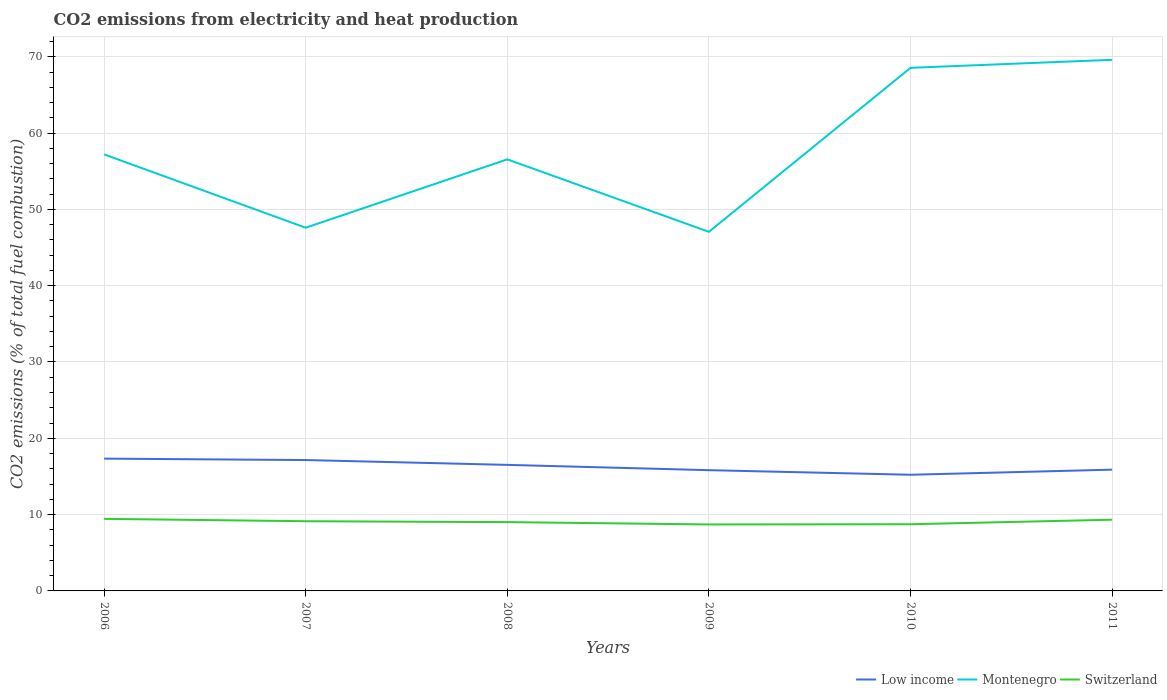Does the line corresponding to Switzerland intersect with the line corresponding to Montenegro?
Your response must be concise. No. Across all years, what is the maximum amount of CO2 emitted in Montenegro?
Give a very brief answer. 47.06. In which year was the amount of CO2 emitted in Low income maximum?
Keep it short and to the point. 2010. What is the total amount of CO2 emitted in Montenegro in the graph?
Keep it short and to the point. -8.96. What is the difference between the highest and the second highest amount of CO2 emitted in Montenegro?
Ensure brevity in your answer.  22.54. What is the difference between the highest and the lowest amount of CO2 emitted in Switzerland?
Your response must be concise. 3. How many lines are there?
Give a very brief answer. 3. What is the difference between two consecutive major ticks on the Y-axis?
Your answer should be compact. 10. Are the values on the major ticks of Y-axis written in scientific E-notation?
Your answer should be compact. No. What is the title of the graph?
Offer a terse response. CO2 emissions from electricity and heat production. What is the label or title of the X-axis?
Provide a short and direct response. Years. What is the label or title of the Y-axis?
Provide a short and direct response. CO2 emissions (% of total fuel combustion). What is the CO2 emissions (% of total fuel combustion) in Low income in 2006?
Ensure brevity in your answer.  17.34. What is the CO2 emissions (% of total fuel combustion) of Montenegro in 2006?
Make the answer very short. 57.21. What is the CO2 emissions (% of total fuel combustion) of Switzerland in 2006?
Offer a very short reply. 9.44. What is the CO2 emissions (% of total fuel combustion) of Low income in 2007?
Provide a short and direct response. 17.15. What is the CO2 emissions (% of total fuel combustion) in Montenegro in 2007?
Offer a terse response. 47.6. What is the CO2 emissions (% of total fuel combustion) in Switzerland in 2007?
Your answer should be compact. 9.13. What is the CO2 emissions (% of total fuel combustion) in Low income in 2008?
Your answer should be very brief. 16.52. What is the CO2 emissions (% of total fuel combustion) in Montenegro in 2008?
Your answer should be very brief. 56.55. What is the CO2 emissions (% of total fuel combustion) in Switzerland in 2008?
Your response must be concise. 9.02. What is the CO2 emissions (% of total fuel combustion) of Low income in 2009?
Offer a terse response. 15.82. What is the CO2 emissions (% of total fuel combustion) in Montenegro in 2009?
Your response must be concise. 47.06. What is the CO2 emissions (% of total fuel combustion) in Switzerland in 2009?
Ensure brevity in your answer.  8.71. What is the CO2 emissions (% of total fuel combustion) of Low income in 2010?
Your answer should be compact. 15.22. What is the CO2 emissions (% of total fuel combustion) of Montenegro in 2010?
Offer a very short reply. 68.55. What is the CO2 emissions (% of total fuel combustion) of Switzerland in 2010?
Provide a succinct answer. 8.74. What is the CO2 emissions (% of total fuel combustion) of Low income in 2011?
Your answer should be compact. 15.89. What is the CO2 emissions (% of total fuel combustion) of Montenegro in 2011?
Ensure brevity in your answer.  69.6. What is the CO2 emissions (% of total fuel combustion) in Switzerland in 2011?
Offer a terse response. 9.33. Across all years, what is the maximum CO2 emissions (% of total fuel combustion) of Low income?
Provide a succinct answer. 17.34. Across all years, what is the maximum CO2 emissions (% of total fuel combustion) of Montenegro?
Your answer should be compact. 69.6. Across all years, what is the maximum CO2 emissions (% of total fuel combustion) of Switzerland?
Your answer should be compact. 9.44. Across all years, what is the minimum CO2 emissions (% of total fuel combustion) in Low income?
Provide a short and direct response. 15.22. Across all years, what is the minimum CO2 emissions (% of total fuel combustion) in Montenegro?
Provide a short and direct response. 47.06. Across all years, what is the minimum CO2 emissions (% of total fuel combustion) of Switzerland?
Give a very brief answer. 8.71. What is the total CO2 emissions (% of total fuel combustion) in Low income in the graph?
Provide a succinct answer. 97.94. What is the total CO2 emissions (% of total fuel combustion) of Montenegro in the graph?
Your answer should be very brief. 346.56. What is the total CO2 emissions (% of total fuel combustion) in Switzerland in the graph?
Keep it short and to the point. 54.38. What is the difference between the CO2 emissions (% of total fuel combustion) in Low income in 2006 and that in 2007?
Ensure brevity in your answer.  0.19. What is the difference between the CO2 emissions (% of total fuel combustion) of Montenegro in 2006 and that in 2007?
Your answer should be compact. 9.61. What is the difference between the CO2 emissions (% of total fuel combustion) of Switzerland in 2006 and that in 2007?
Make the answer very short. 0.31. What is the difference between the CO2 emissions (% of total fuel combustion) in Low income in 2006 and that in 2008?
Provide a short and direct response. 0.82. What is the difference between the CO2 emissions (% of total fuel combustion) of Montenegro in 2006 and that in 2008?
Offer a terse response. 0.65. What is the difference between the CO2 emissions (% of total fuel combustion) in Switzerland in 2006 and that in 2008?
Your response must be concise. 0.43. What is the difference between the CO2 emissions (% of total fuel combustion) of Low income in 2006 and that in 2009?
Your answer should be very brief. 1.51. What is the difference between the CO2 emissions (% of total fuel combustion) in Montenegro in 2006 and that in 2009?
Give a very brief answer. 10.15. What is the difference between the CO2 emissions (% of total fuel combustion) in Switzerland in 2006 and that in 2009?
Your answer should be compact. 0.73. What is the difference between the CO2 emissions (% of total fuel combustion) of Low income in 2006 and that in 2010?
Provide a succinct answer. 2.11. What is the difference between the CO2 emissions (% of total fuel combustion) of Montenegro in 2006 and that in 2010?
Keep it short and to the point. -11.34. What is the difference between the CO2 emissions (% of total fuel combustion) in Switzerland in 2006 and that in 2010?
Ensure brevity in your answer.  0.71. What is the difference between the CO2 emissions (% of total fuel combustion) of Low income in 2006 and that in 2011?
Your response must be concise. 1.44. What is the difference between the CO2 emissions (% of total fuel combustion) of Montenegro in 2006 and that in 2011?
Provide a short and direct response. -12.39. What is the difference between the CO2 emissions (% of total fuel combustion) in Switzerland in 2006 and that in 2011?
Your answer should be very brief. 0.11. What is the difference between the CO2 emissions (% of total fuel combustion) in Low income in 2007 and that in 2008?
Your response must be concise. 0.63. What is the difference between the CO2 emissions (% of total fuel combustion) of Montenegro in 2007 and that in 2008?
Provide a short and direct response. -8.96. What is the difference between the CO2 emissions (% of total fuel combustion) in Switzerland in 2007 and that in 2008?
Your answer should be compact. 0.12. What is the difference between the CO2 emissions (% of total fuel combustion) in Low income in 2007 and that in 2009?
Your answer should be very brief. 1.33. What is the difference between the CO2 emissions (% of total fuel combustion) of Montenegro in 2007 and that in 2009?
Provide a succinct answer. 0.54. What is the difference between the CO2 emissions (% of total fuel combustion) in Switzerland in 2007 and that in 2009?
Offer a very short reply. 0.42. What is the difference between the CO2 emissions (% of total fuel combustion) in Low income in 2007 and that in 2010?
Offer a very short reply. 1.93. What is the difference between the CO2 emissions (% of total fuel combustion) of Montenegro in 2007 and that in 2010?
Give a very brief answer. -20.95. What is the difference between the CO2 emissions (% of total fuel combustion) in Switzerland in 2007 and that in 2010?
Ensure brevity in your answer.  0.4. What is the difference between the CO2 emissions (% of total fuel combustion) of Low income in 2007 and that in 2011?
Provide a succinct answer. 1.26. What is the difference between the CO2 emissions (% of total fuel combustion) in Montenegro in 2007 and that in 2011?
Give a very brief answer. -22. What is the difference between the CO2 emissions (% of total fuel combustion) in Switzerland in 2007 and that in 2011?
Ensure brevity in your answer.  -0.2. What is the difference between the CO2 emissions (% of total fuel combustion) in Low income in 2008 and that in 2009?
Give a very brief answer. 0.69. What is the difference between the CO2 emissions (% of total fuel combustion) of Montenegro in 2008 and that in 2009?
Keep it short and to the point. 9.5. What is the difference between the CO2 emissions (% of total fuel combustion) in Switzerland in 2008 and that in 2009?
Your answer should be compact. 0.31. What is the difference between the CO2 emissions (% of total fuel combustion) of Low income in 2008 and that in 2010?
Give a very brief answer. 1.29. What is the difference between the CO2 emissions (% of total fuel combustion) in Montenegro in 2008 and that in 2010?
Your answer should be compact. -11.99. What is the difference between the CO2 emissions (% of total fuel combustion) of Switzerland in 2008 and that in 2010?
Keep it short and to the point. 0.28. What is the difference between the CO2 emissions (% of total fuel combustion) of Low income in 2008 and that in 2011?
Keep it short and to the point. 0.63. What is the difference between the CO2 emissions (% of total fuel combustion) in Montenegro in 2008 and that in 2011?
Your answer should be compact. -13.05. What is the difference between the CO2 emissions (% of total fuel combustion) of Switzerland in 2008 and that in 2011?
Provide a succinct answer. -0.31. What is the difference between the CO2 emissions (% of total fuel combustion) in Low income in 2009 and that in 2010?
Keep it short and to the point. 0.6. What is the difference between the CO2 emissions (% of total fuel combustion) in Montenegro in 2009 and that in 2010?
Ensure brevity in your answer.  -21.49. What is the difference between the CO2 emissions (% of total fuel combustion) of Switzerland in 2009 and that in 2010?
Your answer should be very brief. -0.03. What is the difference between the CO2 emissions (% of total fuel combustion) in Low income in 2009 and that in 2011?
Your response must be concise. -0.07. What is the difference between the CO2 emissions (% of total fuel combustion) of Montenegro in 2009 and that in 2011?
Make the answer very short. -22.54. What is the difference between the CO2 emissions (% of total fuel combustion) in Switzerland in 2009 and that in 2011?
Ensure brevity in your answer.  -0.62. What is the difference between the CO2 emissions (% of total fuel combustion) in Low income in 2010 and that in 2011?
Offer a terse response. -0.67. What is the difference between the CO2 emissions (% of total fuel combustion) in Montenegro in 2010 and that in 2011?
Your answer should be very brief. -1.05. What is the difference between the CO2 emissions (% of total fuel combustion) in Switzerland in 2010 and that in 2011?
Offer a terse response. -0.59. What is the difference between the CO2 emissions (% of total fuel combustion) of Low income in 2006 and the CO2 emissions (% of total fuel combustion) of Montenegro in 2007?
Provide a succinct answer. -30.26. What is the difference between the CO2 emissions (% of total fuel combustion) of Low income in 2006 and the CO2 emissions (% of total fuel combustion) of Switzerland in 2007?
Offer a terse response. 8.2. What is the difference between the CO2 emissions (% of total fuel combustion) in Montenegro in 2006 and the CO2 emissions (% of total fuel combustion) in Switzerland in 2007?
Keep it short and to the point. 48.07. What is the difference between the CO2 emissions (% of total fuel combustion) of Low income in 2006 and the CO2 emissions (% of total fuel combustion) of Montenegro in 2008?
Keep it short and to the point. -39.22. What is the difference between the CO2 emissions (% of total fuel combustion) in Low income in 2006 and the CO2 emissions (% of total fuel combustion) in Switzerland in 2008?
Offer a very short reply. 8.32. What is the difference between the CO2 emissions (% of total fuel combustion) of Montenegro in 2006 and the CO2 emissions (% of total fuel combustion) of Switzerland in 2008?
Your answer should be very brief. 48.19. What is the difference between the CO2 emissions (% of total fuel combustion) of Low income in 2006 and the CO2 emissions (% of total fuel combustion) of Montenegro in 2009?
Keep it short and to the point. -29.72. What is the difference between the CO2 emissions (% of total fuel combustion) of Low income in 2006 and the CO2 emissions (% of total fuel combustion) of Switzerland in 2009?
Make the answer very short. 8.62. What is the difference between the CO2 emissions (% of total fuel combustion) of Montenegro in 2006 and the CO2 emissions (% of total fuel combustion) of Switzerland in 2009?
Your answer should be very brief. 48.5. What is the difference between the CO2 emissions (% of total fuel combustion) in Low income in 2006 and the CO2 emissions (% of total fuel combustion) in Montenegro in 2010?
Ensure brevity in your answer.  -51.21. What is the difference between the CO2 emissions (% of total fuel combustion) in Low income in 2006 and the CO2 emissions (% of total fuel combustion) in Switzerland in 2010?
Your response must be concise. 8.6. What is the difference between the CO2 emissions (% of total fuel combustion) of Montenegro in 2006 and the CO2 emissions (% of total fuel combustion) of Switzerland in 2010?
Your answer should be compact. 48.47. What is the difference between the CO2 emissions (% of total fuel combustion) of Low income in 2006 and the CO2 emissions (% of total fuel combustion) of Montenegro in 2011?
Offer a terse response. -52.26. What is the difference between the CO2 emissions (% of total fuel combustion) of Low income in 2006 and the CO2 emissions (% of total fuel combustion) of Switzerland in 2011?
Provide a short and direct response. 8. What is the difference between the CO2 emissions (% of total fuel combustion) in Montenegro in 2006 and the CO2 emissions (% of total fuel combustion) in Switzerland in 2011?
Ensure brevity in your answer.  47.87. What is the difference between the CO2 emissions (% of total fuel combustion) of Low income in 2007 and the CO2 emissions (% of total fuel combustion) of Montenegro in 2008?
Give a very brief answer. -39.4. What is the difference between the CO2 emissions (% of total fuel combustion) of Low income in 2007 and the CO2 emissions (% of total fuel combustion) of Switzerland in 2008?
Ensure brevity in your answer.  8.13. What is the difference between the CO2 emissions (% of total fuel combustion) in Montenegro in 2007 and the CO2 emissions (% of total fuel combustion) in Switzerland in 2008?
Your answer should be very brief. 38.58. What is the difference between the CO2 emissions (% of total fuel combustion) of Low income in 2007 and the CO2 emissions (% of total fuel combustion) of Montenegro in 2009?
Ensure brevity in your answer.  -29.91. What is the difference between the CO2 emissions (% of total fuel combustion) in Low income in 2007 and the CO2 emissions (% of total fuel combustion) in Switzerland in 2009?
Ensure brevity in your answer.  8.44. What is the difference between the CO2 emissions (% of total fuel combustion) in Montenegro in 2007 and the CO2 emissions (% of total fuel combustion) in Switzerland in 2009?
Offer a terse response. 38.89. What is the difference between the CO2 emissions (% of total fuel combustion) in Low income in 2007 and the CO2 emissions (% of total fuel combustion) in Montenegro in 2010?
Your answer should be compact. -51.4. What is the difference between the CO2 emissions (% of total fuel combustion) in Low income in 2007 and the CO2 emissions (% of total fuel combustion) in Switzerland in 2010?
Ensure brevity in your answer.  8.41. What is the difference between the CO2 emissions (% of total fuel combustion) of Montenegro in 2007 and the CO2 emissions (% of total fuel combustion) of Switzerland in 2010?
Your response must be concise. 38.86. What is the difference between the CO2 emissions (% of total fuel combustion) of Low income in 2007 and the CO2 emissions (% of total fuel combustion) of Montenegro in 2011?
Make the answer very short. -52.45. What is the difference between the CO2 emissions (% of total fuel combustion) of Low income in 2007 and the CO2 emissions (% of total fuel combustion) of Switzerland in 2011?
Give a very brief answer. 7.82. What is the difference between the CO2 emissions (% of total fuel combustion) of Montenegro in 2007 and the CO2 emissions (% of total fuel combustion) of Switzerland in 2011?
Your answer should be very brief. 38.26. What is the difference between the CO2 emissions (% of total fuel combustion) of Low income in 2008 and the CO2 emissions (% of total fuel combustion) of Montenegro in 2009?
Make the answer very short. -30.54. What is the difference between the CO2 emissions (% of total fuel combustion) of Low income in 2008 and the CO2 emissions (% of total fuel combustion) of Switzerland in 2009?
Provide a succinct answer. 7.81. What is the difference between the CO2 emissions (% of total fuel combustion) of Montenegro in 2008 and the CO2 emissions (% of total fuel combustion) of Switzerland in 2009?
Offer a terse response. 47.84. What is the difference between the CO2 emissions (% of total fuel combustion) in Low income in 2008 and the CO2 emissions (% of total fuel combustion) in Montenegro in 2010?
Ensure brevity in your answer.  -52.03. What is the difference between the CO2 emissions (% of total fuel combustion) in Low income in 2008 and the CO2 emissions (% of total fuel combustion) in Switzerland in 2010?
Your answer should be very brief. 7.78. What is the difference between the CO2 emissions (% of total fuel combustion) of Montenegro in 2008 and the CO2 emissions (% of total fuel combustion) of Switzerland in 2010?
Offer a terse response. 47.82. What is the difference between the CO2 emissions (% of total fuel combustion) of Low income in 2008 and the CO2 emissions (% of total fuel combustion) of Montenegro in 2011?
Make the answer very short. -53.08. What is the difference between the CO2 emissions (% of total fuel combustion) in Low income in 2008 and the CO2 emissions (% of total fuel combustion) in Switzerland in 2011?
Ensure brevity in your answer.  7.19. What is the difference between the CO2 emissions (% of total fuel combustion) of Montenegro in 2008 and the CO2 emissions (% of total fuel combustion) of Switzerland in 2011?
Your answer should be very brief. 47.22. What is the difference between the CO2 emissions (% of total fuel combustion) in Low income in 2009 and the CO2 emissions (% of total fuel combustion) in Montenegro in 2010?
Provide a short and direct response. -52.72. What is the difference between the CO2 emissions (% of total fuel combustion) in Low income in 2009 and the CO2 emissions (% of total fuel combustion) in Switzerland in 2010?
Your answer should be compact. 7.09. What is the difference between the CO2 emissions (% of total fuel combustion) of Montenegro in 2009 and the CO2 emissions (% of total fuel combustion) of Switzerland in 2010?
Offer a terse response. 38.32. What is the difference between the CO2 emissions (% of total fuel combustion) of Low income in 2009 and the CO2 emissions (% of total fuel combustion) of Montenegro in 2011?
Offer a very short reply. -53.78. What is the difference between the CO2 emissions (% of total fuel combustion) in Low income in 2009 and the CO2 emissions (% of total fuel combustion) in Switzerland in 2011?
Keep it short and to the point. 6.49. What is the difference between the CO2 emissions (% of total fuel combustion) of Montenegro in 2009 and the CO2 emissions (% of total fuel combustion) of Switzerland in 2011?
Your answer should be compact. 37.73. What is the difference between the CO2 emissions (% of total fuel combustion) in Low income in 2010 and the CO2 emissions (% of total fuel combustion) in Montenegro in 2011?
Your answer should be compact. -54.38. What is the difference between the CO2 emissions (% of total fuel combustion) in Low income in 2010 and the CO2 emissions (% of total fuel combustion) in Switzerland in 2011?
Offer a very short reply. 5.89. What is the difference between the CO2 emissions (% of total fuel combustion) in Montenegro in 2010 and the CO2 emissions (% of total fuel combustion) in Switzerland in 2011?
Provide a short and direct response. 59.22. What is the average CO2 emissions (% of total fuel combustion) in Low income per year?
Make the answer very short. 16.32. What is the average CO2 emissions (% of total fuel combustion) in Montenegro per year?
Offer a very short reply. 57.76. What is the average CO2 emissions (% of total fuel combustion) of Switzerland per year?
Make the answer very short. 9.06. In the year 2006, what is the difference between the CO2 emissions (% of total fuel combustion) in Low income and CO2 emissions (% of total fuel combustion) in Montenegro?
Keep it short and to the point. -39.87. In the year 2006, what is the difference between the CO2 emissions (% of total fuel combustion) in Low income and CO2 emissions (% of total fuel combustion) in Switzerland?
Your answer should be very brief. 7.89. In the year 2006, what is the difference between the CO2 emissions (% of total fuel combustion) in Montenegro and CO2 emissions (% of total fuel combustion) in Switzerland?
Offer a terse response. 47.76. In the year 2007, what is the difference between the CO2 emissions (% of total fuel combustion) in Low income and CO2 emissions (% of total fuel combustion) in Montenegro?
Your response must be concise. -30.45. In the year 2007, what is the difference between the CO2 emissions (% of total fuel combustion) in Low income and CO2 emissions (% of total fuel combustion) in Switzerland?
Provide a succinct answer. 8.02. In the year 2007, what is the difference between the CO2 emissions (% of total fuel combustion) in Montenegro and CO2 emissions (% of total fuel combustion) in Switzerland?
Ensure brevity in your answer.  38.46. In the year 2008, what is the difference between the CO2 emissions (% of total fuel combustion) in Low income and CO2 emissions (% of total fuel combustion) in Montenegro?
Make the answer very short. -40.04. In the year 2008, what is the difference between the CO2 emissions (% of total fuel combustion) of Low income and CO2 emissions (% of total fuel combustion) of Switzerland?
Ensure brevity in your answer.  7.5. In the year 2008, what is the difference between the CO2 emissions (% of total fuel combustion) in Montenegro and CO2 emissions (% of total fuel combustion) in Switzerland?
Provide a succinct answer. 47.54. In the year 2009, what is the difference between the CO2 emissions (% of total fuel combustion) of Low income and CO2 emissions (% of total fuel combustion) of Montenegro?
Provide a short and direct response. -31.23. In the year 2009, what is the difference between the CO2 emissions (% of total fuel combustion) in Low income and CO2 emissions (% of total fuel combustion) in Switzerland?
Make the answer very short. 7.11. In the year 2009, what is the difference between the CO2 emissions (% of total fuel combustion) in Montenegro and CO2 emissions (% of total fuel combustion) in Switzerland?
Keep it short and to the point. 38.35. In the year 2010, what is the difference between the CO2 emissions (% of total fuel combustion) of Low income and CO2 emissions (% of total fuel combustion) of Montenegro?
Provide a short and direct response. -53.32. In the year 2010, what is the difference between the CO2 emissions (% of total fuel combustion) in Low income and CO2 emissions (% of total fuel combustion) in Switzerland?
Your answer should be very brief. 6.49. In the year 2010, what is the difference between the CO2 emissions (% of total fuel combustion) of Montenegro and CO2 emissions (% of total fuel combustion) of Switzerland?
Provide a short and direct response. 59.81. In the year 2011, what is the difference between the CO2 emissions (% of total fuel combustion) in Low income and CO2 emissions (% of total fuel combustion) in Montenegro?
Provide a succinct answer. -53.71. In the year 2011, what is the difference between the CO2 emissions (% of total fuel combustion) of Low income and CO2 emissions (% of total fuel combustion) of Switzerland?
Your answer should be compact. 6.56. In the year 2011, what is the difference between the CO2 emissions (% of total fuel combustion) of Montenegro and CO2 emissions (% of total fuel combustion) of Switzerland?
Provide a succinct answer. 60.27. What is the ratio of the CO2 emissions (% of total fuel combustion) in Low income in 2006 to that in 2007?
Your answer should be very brief. 1.01. What is the ratio of the CO2 emissions (% of total fuel combustion) of Montenegro in 2006 to that in 2007?
Offer a very short reply. 1.2. What is the ratio of the CO2 emissions (% of total fuel combustion) of Switzerland in 2006 to that in 2007?
Your response must be concise. 1.03. What is the ratio of the CO2 emissions (% of total fuel combustion) of Low income in 2006 to that in 2008?
Offer a terse response. 1.05. What is the ratio of the CO2 emissions (% of total fuel combustion) in Montenegro in 2006 to that in 2008?
Your response must be concise. 1.01. What is the ratio of the CO2 emissions (% of total fuel combustion) of Switzerland in 2006 to that in 2008?
Your answer should be very brief. 1.05. What is the ratio of the CO2 emissions (% of total fuel combustion) of Low income in 2006 to that in 2009?
Ensure brevity in your answer.  1.1. What is the ratio of the CO2 emissions (% of total fuel combustion) of Montenegro in 2006 to that in 2009?
Ensure brevity in your answer.  1.22. What is the ratio of the CO2 emissions (% of total fuel combustion) of Switzerland in 2006 to that in 2009?
Provide a succinct answer. 1.08. What is the ratio of the CO2 emissions (% of total fuel combustion) of Low income in 2006 to that in 2010?
Provide a short and direct response. 1.14. What is the ratio of the CO2 emissions (% of total fuel combustion) in Montenegro in 2006 to that in 2010?
Provide a short and direct response. 0.83. What is the ratio of the CO2 emissions (% of total fuel combustion) in Switzerland in 2006 to that in 2010?
Make the answer very short. 1.08. What is the ratio of the CO2 emissions (% of total fuel combustion) of Montenegro in 2006 to that in 2011?
Offer a terse response. 0.82. What is the ratio of the CO2 emissions (% of total fuel combustion) of Low income in 2007 to that in 2008?
Ensure brevity in your answer.  1.04. What is the ratio of the CO2 emissions (% of total fuel combustion) in Montenegro in 2007 to that in 2008?
Give a very brief answer. 0.84. What is the ratio of the CO2 emissions (% of total fuel combustion) of Switzerland in 2007 to that in 2008?
Your answer should be compact. 1.01. What is the ratio of the CO2 emissions (% of total fuel combustion) in Low income in 2007 to that in 2009?
Provide a succinct answer. 1.08. What is the ratio of the CO2 emissions (% of total fuel combustion) of Montenegro in 2007 to that in 2009?
Your response must be concise. 1.01. What is the ratio of the CO2 emissions (% of total fuel combustion) in Switzerland in 2007 to that in 2009?
Offer a very short reply. 1.05. What is the ratio of the CO2 emissions (% of total fuel combustion) of Low income in 2007 to that in 2010?
Provide a short and direct response. 1.13. What is the ratio of the CO2 emissions (% of total fuel combustion) of Montenegro in 2007 to that in 2010?
Your answer should be compact. 0.69. What is the ratio of the CO2 emissions (% of total fuel combustion) in Switzerland in 2007 to that in 2010?
Provide a short and direct response. 1.05. What is the ratio of the CO2 emissions (% of total fuel combustion) in Low income in 2007 to that in 2011?
Offer a very short reply. 1.08. What is the ratio of the CO2 emissions (% of total fuel combustion) in Montenegro in 2007 to that in 2011?
Offer a terse response. 0.68. What is the ratio of the CO2 emissions (% of total fuel combustion) in Switzerland in 2007 to that in 2011?
Keep it short and to the point. 0.98. What is the ratio of the CO2 emissions (% of total fuel combustion) in Low income in 2008 to that in 2009?
Offer a very short reply. 1.04. What is the ratio of the CO2 emissions (% of total fuel combustion) in Montenegro in 2008 to that in 2009?
Provide a succinct answer. 1.2. What is the ratio of the CO2 emissions (% of total fuel combustion) in Switzerland in 2008 to that in 2009?
Give a very brief answer. 1.04. What is the ratio of the CO2 emissions (% of total fuel combustion) in Low income in 2008 to that in 2010?
Provide a short and direct response. 1.08. What is the ratio of the CO2 emissions (% of total fuel combustion) in Montenegro in 2008 to that in 2010?
Offer a very short reply. 0.82. What is the ratio of the CO2 emissions (% of total fuel combustion) of Switzerland in 2008 to that in 2010?
Ensure brevity in your answer.  1.03. What is the ratio of the CO2 emissions (% of total fuel combustion) of Low income in 2008 to that in 2011?
Provide a short and direct response. 1.04. What is the ratio of the CO2 emissions (% of total fuel combustion) in Montenegro in 2008 to that in 2011?
Offer a terse response. 0.81. What is the ratio of the CO2 emissions (% of total fuel combustion) in Switzerland in 2008 to that in 2011?
Your answer should be compact. 0.97. What is the ratio of the CO2 emissions (% of total fuel combustion) of Low income in 2009 to that in 2010?
Offer a terse response. 1.04. What is the ratio of the CO2 emissions (% of total fuel combustion) of Montenegro in 2009 to that in 2010?
Your answer should be compact. 0.69. What is the ratio of the CO2 emissions (% of total fuel combustion) in Low income in 2009 to that in 2011?
Keep it short and to the point. 1. What is the ratio of the CO2 emissions (% of total fuel combustion) of Montenegro in 2009 to that in 2011?
Your answer should be very brief. 0.68. What is the ratio of the CO2 emissions (% of total fuel combustion) of Switzerland in 2009 to that in 2011?
Give a very brief answer. 0.93. What is the ratio of the CO2 emissions (% of total fuel combustion) in Low income in 2010 to that in 2011?
Your answer should be very brief. 0.96. What is the ratio of the CO2 emissions (% of total fuel combustion) of Montenegro in 2010 to that in 2011?
Keep it short and to the point. 0.98. What is the ratio of the CO2 emissions (% of total fuel combustion) of Switzerland in 2010 to that in 2011?
Your answer should be compact. 0.94. What is the difference between the highest and the second highest CO2 emissions (% of total fuel combustion) of Low income?
Provide a short and direct response. 0.19. What is the difference between the highest and the second highest CO2 emissions (% of total fuel combustion) in Montenegro?
Provide a succinct answer. 1.05. What is the difference between the highest and the second highest CO2 emissions (% of total fuel combustion) of Switzerland?
Ensure brevity in your answer.  0.11. What is the difference between the highest and the lowest CO2 emissions (% of total fuel combustion) of Low income?
Provide a short and direct response. 2.11. What is the difference between the highest and the lowest CO2 emissions (% of total fuel combustion) in Montenegro?
Your answer should be compact. 22.54. What is the difference between the highest and the lowest CO2 emissions (% of total fuel combustion) of Switzerland?
Keep it short and to the point. 0.73. 